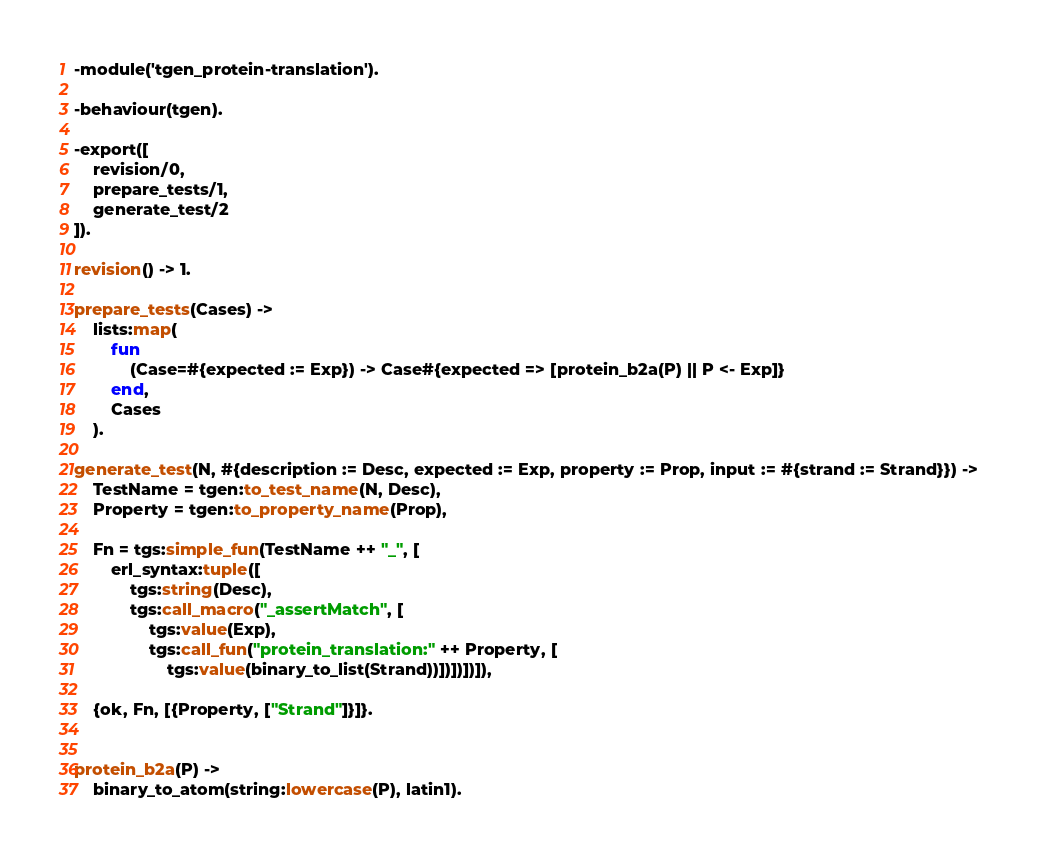Convert code to text. <code><loc_0><loc_0><loc_500><loc_500><_Erlang_>-module('tgen_protein-translation').

-behaviour(tgen).

-export([
    revision/0,
    prepare_tests/1,
    generate_test/2
]).

revision() -> 1.

prepare_tests(Cases) ->
    lists:map(
        fun
            (Case=#{expected := Exp}) -> Case#{expected => [protein_b2a(P) || P <- Exp]}
        end,
        Cases
    ).

generate_test(N, #{description := Desc, expected := Exp, property := Prop, input := #{strand := Strand}}) ->
    TestName = tgen:to_test_name(N, Desc),
    Property = tgen:to_property_name(Prop),

    Fn = tgs:simple_fun(TestName ++ "_", [
        erl_syntax:tuple([
            tgs:string(Desc),
            tgs:call_macro("_assertMatch", [
                tgs:value(Exp),
                tgs:call_fun("protein_translation:" ++ Property, [
                    tgs:value(binary_to_list(Strand))])])])]),

    {ok, Fn, [{Property, ["Strand"]}]}.


protein_b2a(P) ->
    binary_to_atom(string:lowercase(P), latin1).
</code> 